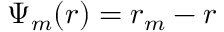<formula> <loc_0><loc_0><loc_500><loc_500>\Psi _ { m } ( r ) = r _ { m } - r</formula> 